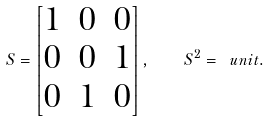<formula> <loc_0><loc_0><loc_500><loc_500>S = \begin{bmatrix} 1 & 0 & 0 \\ 0 & 0 & 1 \\ 0 & 1 & 0 \end{bmatrix} , \quad S ^ { 2 } = \ u n i t .</formula> 